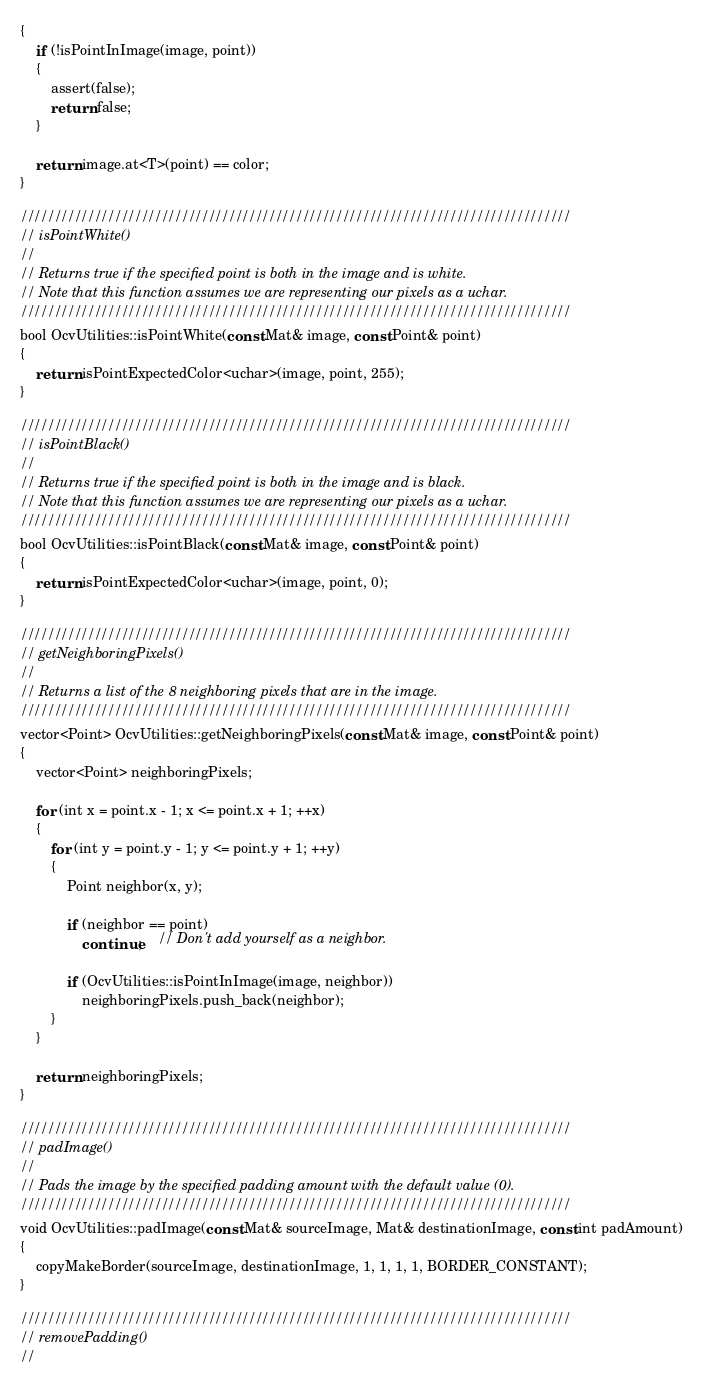Convert code to text. <code><loc_0><loc_0><loc_500><loc_500><_C++_>{
	if (!isPointInImage(image, point))
	{
		assert(false);
		return false;
	}

	return image.at<T>(point) == color;
}

//////////////////////////////////////////////////////////////////////////////////
// isPointWhite()
//
// Returns true if the specified point is both in the image and is white.
// Note that this function assumes we are representing our pixels as a uchar.
//////////////////////////////////////////////////////////////////////////////////
bool OcvUtilities::isPointWhite(const Mat& image, const Point& point)
{
	return isPointExpectedColor<uchar>(image, point, 255);
}

//////////////////////////////////////////////////////////////////////////////////
// isPointBlack()
//
// Returns true if the specified point is both in the image and is black.
// Note that this function assumes we are representing our pixels as a uchar.
//////////////////////////////////////////////////////////////////////////////////
bool OcvUtilities::isPointBlack(const Mat& image, const Point& point)
{
	return isPointExpectedColor<uchar>(image, point, 0);
}

//////////////////////////////////////////////////////////////////////////////////
// getNeighboringPixels()
//
// Returns a list of the 8 neighboring pixels that are in the image.
//////////////////////////////////////////////////////////////////////////////////
vector<Point> OcvUtilities::getNeighboringPixels(const Mat& image, const Point& point)
{
	vector<Point> neighboringPixels;

	for (int x = point.x - 1; x <= point.x + 1; ++x)
	{
		for (int y = point.y - 1; y <= point.y + 1; ++y)
		{
			Point neighbor(x, y);
			
			if (neighbor == point)
				continue;	// Don't add yourself as a neighbor.

			if (OcvUtilities::isPointInImage(image, neighbor))
				neighboringPixels.push_back(neighbor);
		}
	}

	return neighboringPixels;
}

//////////////////////////////////////////////////////////////////////////////////
// padImage()
//
// Pads the image by the specified padding amount with the default value (0).
//////////////////////////////////////////////////////////////////////////////////
void OcvUtilities::padImage(const Mat& sourceImage, Mat& destinationImage, const int padAmount)
{
	copyMakeBorder(sourceImage, destinationImage, 1, 1, 1, 1, BORDER_CONSTANT);
}

//////////////////////////////////////////////////////////////////////////////////
// removePadding()
//</code> 